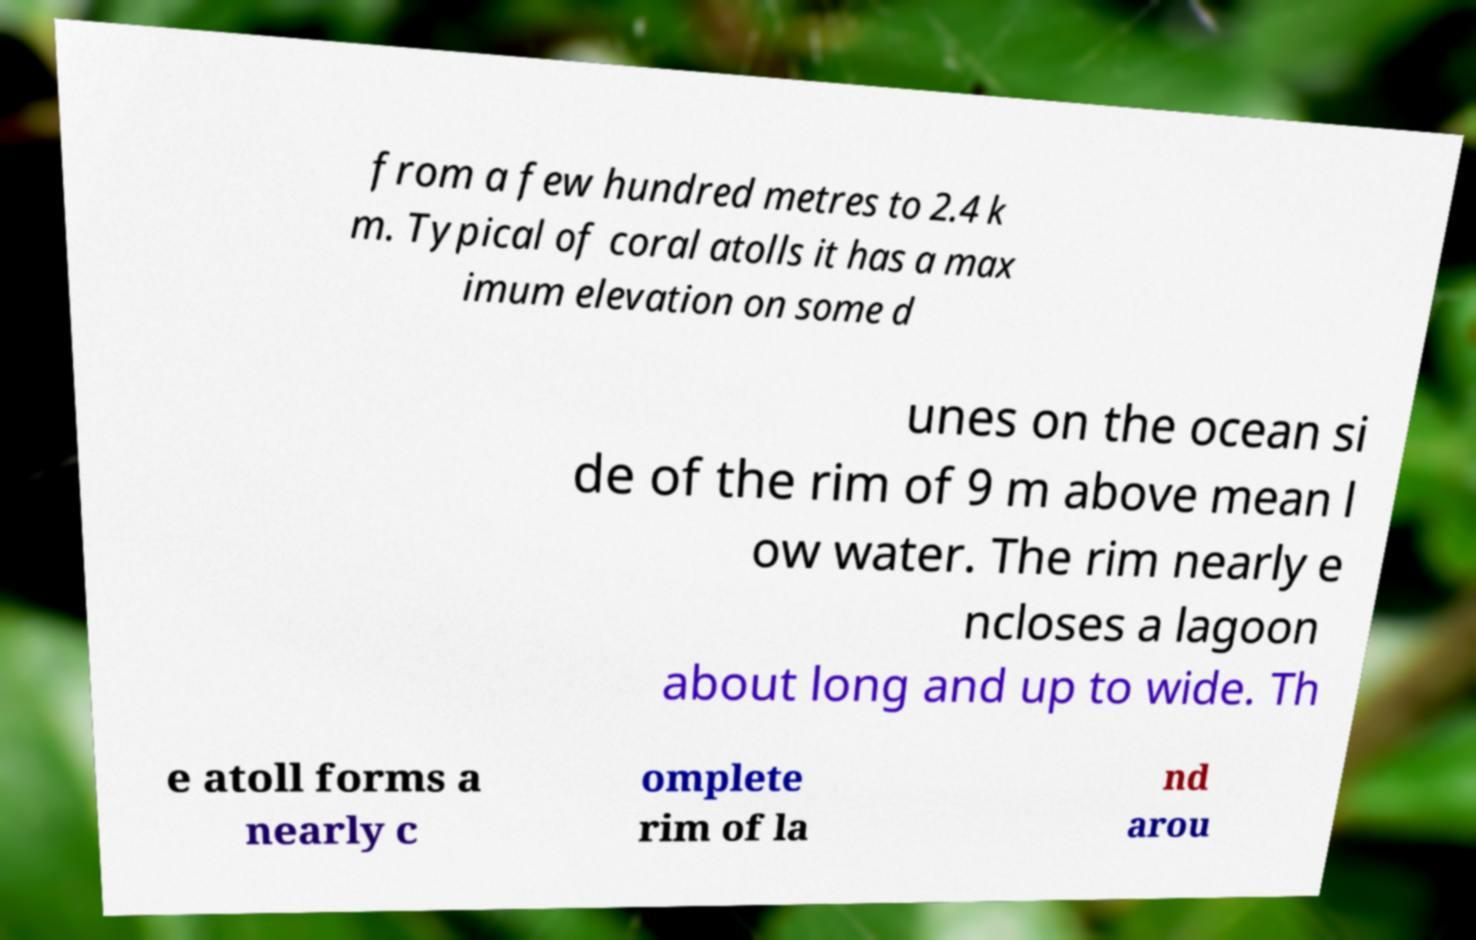There's text embedded in this image that I need extracted. Can you transcribe it verbatim? from a few hundred metres to 2.4 k m. Typical of coral atolls it has a max imum elevation on some d unes on the ocean si de of the rim of 9 m above mean l ow water. The rim nearly e ncloses a lagoon about long and up to wide. Th e atoll forms a nearly c omplete rim of la nd arou 